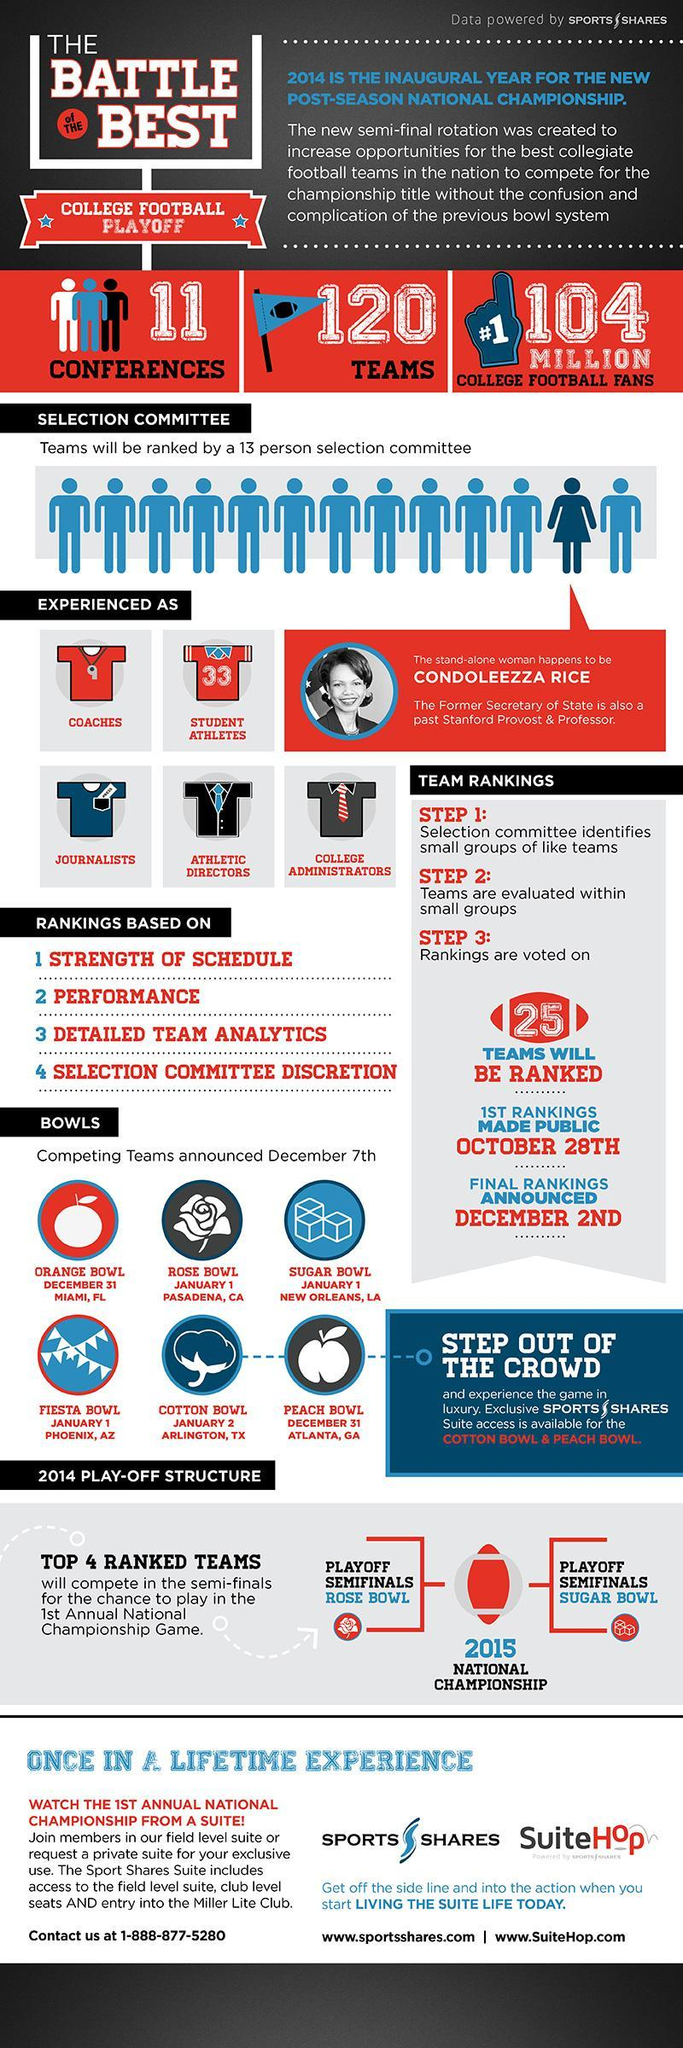How many males in the 13 person selection committee?
Answer the question with a short phrase. 12 At which location is the Fiesta Bowl scheduled to be played? Phoenix, AZ How many teams will be ranked by the selection committee? 25 Which Bowl is scheduled to be held at Atlanta, GA on December 31? Peach Bowl When is the Orange bowl match scheduled to be held? December 31 Who is the female member in the selection committee? Condoleezza Rice How many Bowl games are listed? 6 How many females in the 13 person selection committee? 1 Which past Stanford Provost and Professor is mentioned in this infographic? Condoleezza Rice Which event is scheduled to be held on January 1 at Pasadena, CA? Rose Bowl 